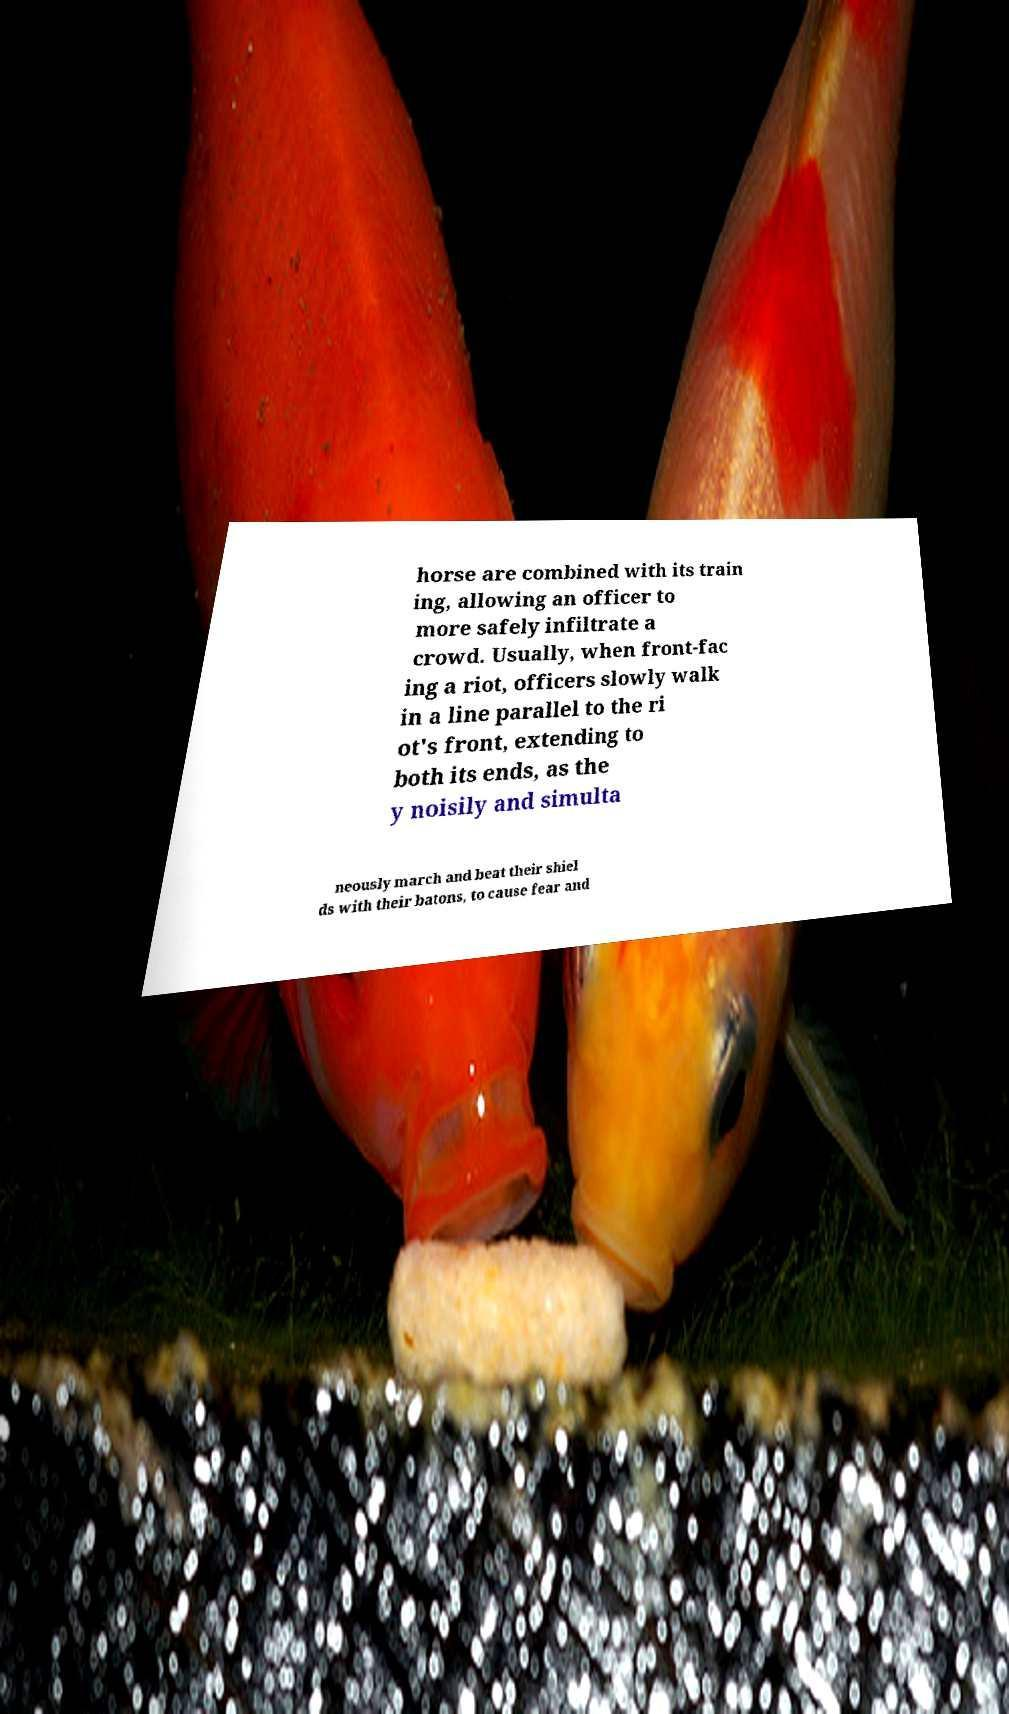Could you extract and type out the text from this image? horse are combined with its train ing, allowing an officer to more safely infiltrate a crowd. Usually, when front-fac ing a riot, officers slowly walk in a line parallel to the ri ot's front, extending to both its ends, as the y noisily and simulta neously march and beat their shiel ds with their batons, to cause fear and 